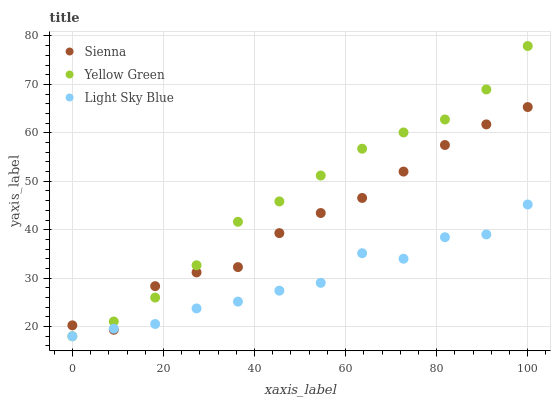Does Light Sky Blue have the minimum area under the curve?
Answer yes or no. Yes. Does Yellow Green have the maximum area under the curve?
Answer yes or no. Yes. Does Yellow Green have the minimum area under the curve?
Answer yes or no. No. Does Light Sky Blue have the maximum area under the curve?
Answer yes or no. No. Is Yellow Green the smoothest?
Answer yes or no. Yes. Is Light Sky Blue the roughest?
Answer yes or no. Yes. Is Light Sky Blue the smoothest?
Answer yes or no. No. Is Yellow Green the roughest?
Answer yes or no. No. Does Light Sky Blue have the lowest value?
Answer yes or no. Yes. Does Yellow Green have the highest value?
Answer yes or no. Yes. Does Light Sky Blue have the highest value?
Answer yes or no. No. Does Yellow Green intersect Sienna?
Answer yes or no. Yes. Is Yellow Green less than Sienna?
Answer yes or no. No. Is Yellow Green greater than Sienna?
Answer yes or no. No. 